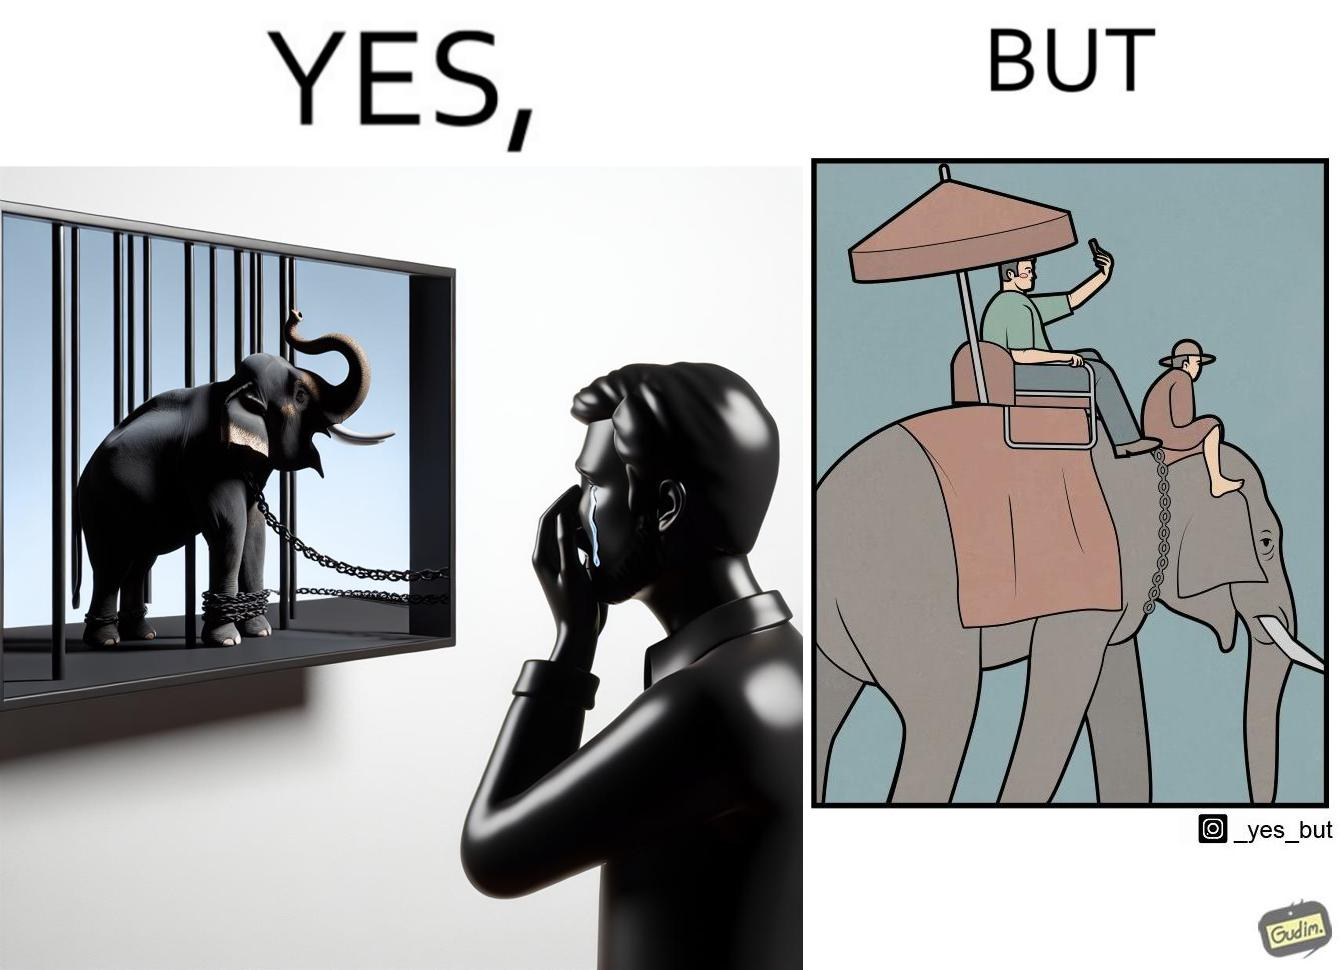What is the satirical meaning behind this image? The image is ironic, because the people who get sentimental over imprisoned animal while watching TV shows often feel okay when using animals for labor 